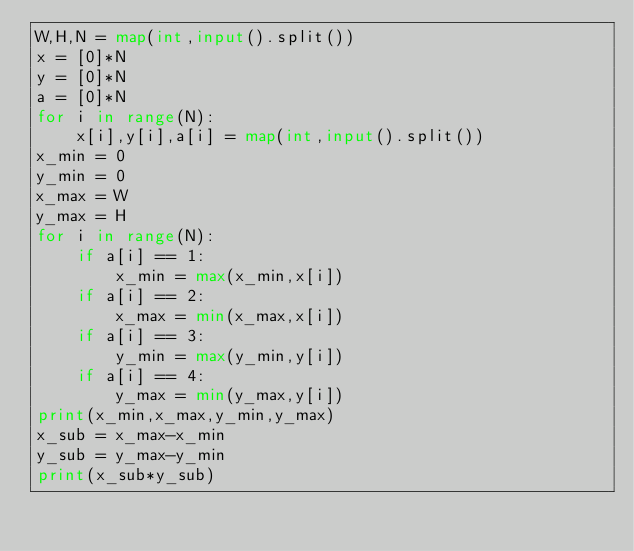<code> <loc_0><loc_0><loc_500><loc_500><_Python_>W,H,N = map(int,input().split())
x = [0]*N
y = [0]*N
a = [0]*N
for i in range(N):
    x[i],y[i],a[i] = map(int,input().split())
x_min = 0
y_min = 0
x_max = W
y_max = H
for i in range(N):
    if a[i] == 1:
        x_min = max(x_min,x[i])
    if a[i] == 2:
        x_max = min(x_max,x[i])
    if a[i] == 3:
        y_min = max(y_min,y[i])
    if a[i] == 4:
        y_max = min(y_max,y[i])
print(x_min,x_max,y_min,y_max)
x_sub = x_max-x_min
y_sub = y_max-y_min
print(x_sub*y_sub)</code> 